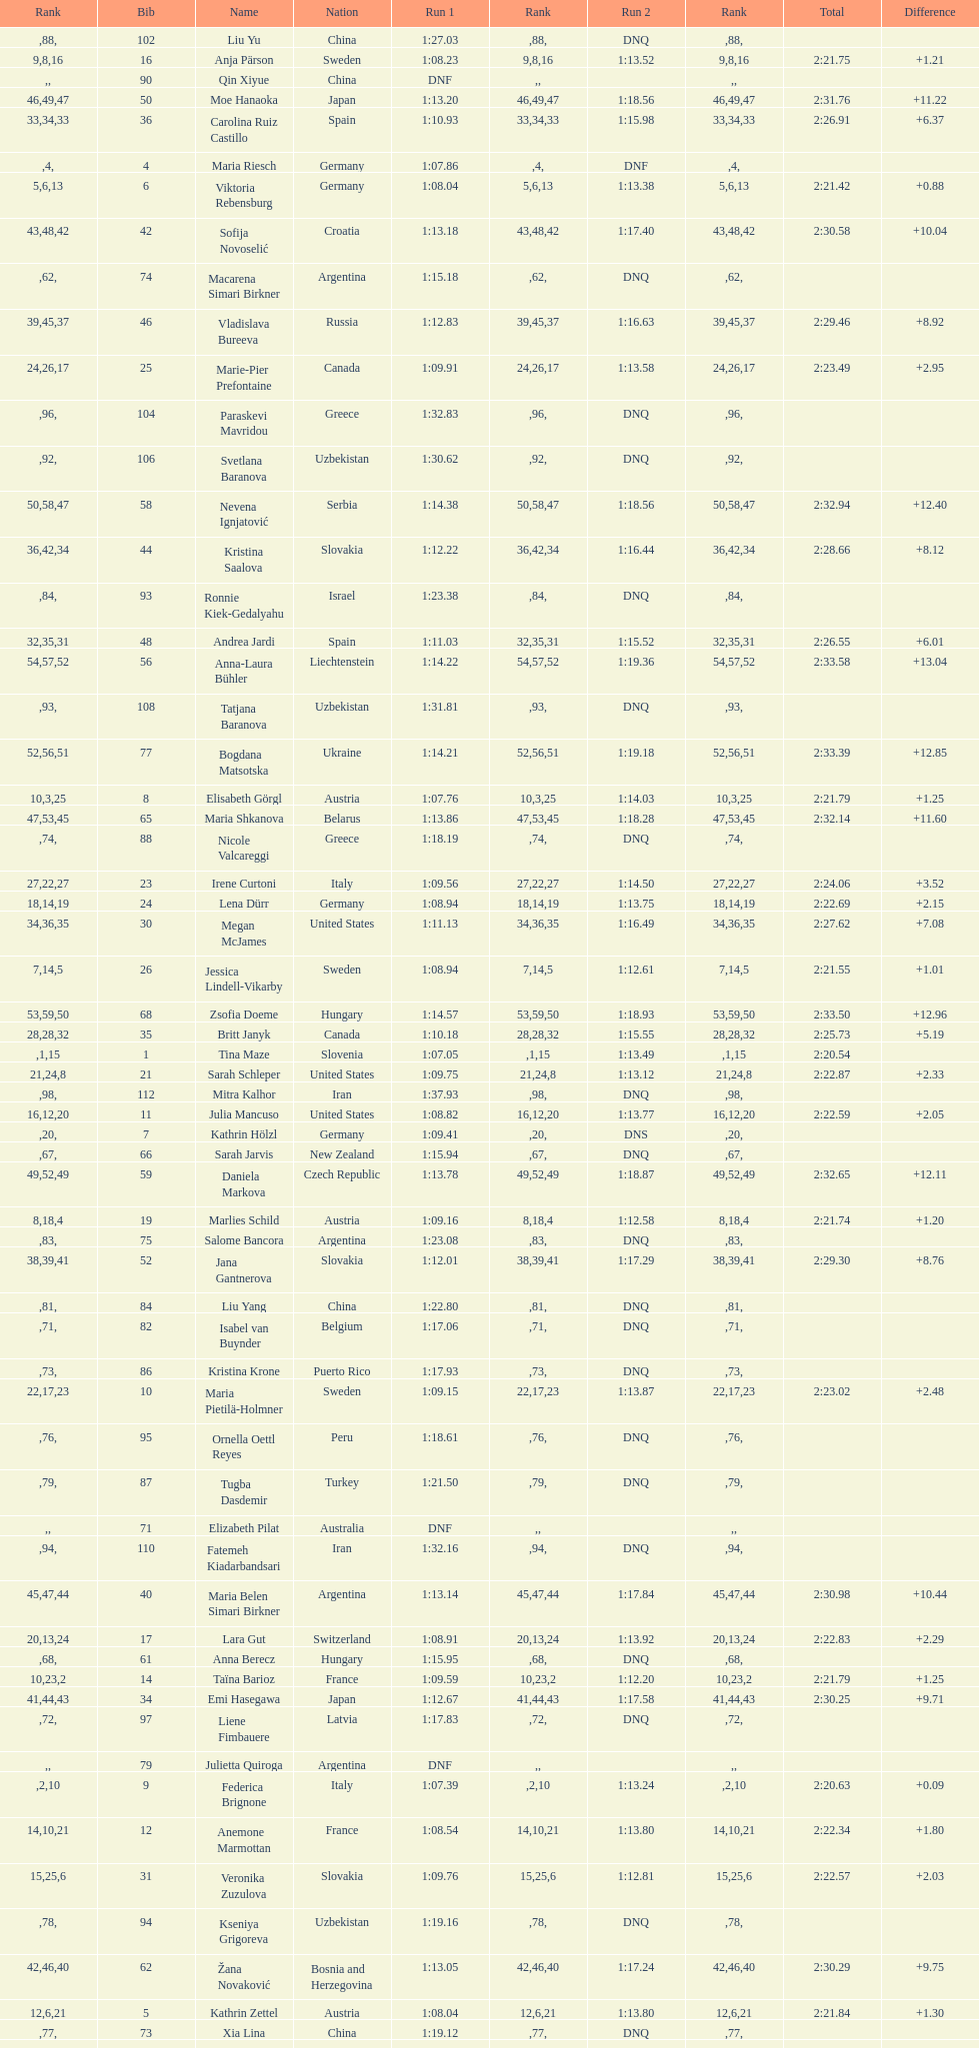What is the last nation to be ranked? Czech Republic. 